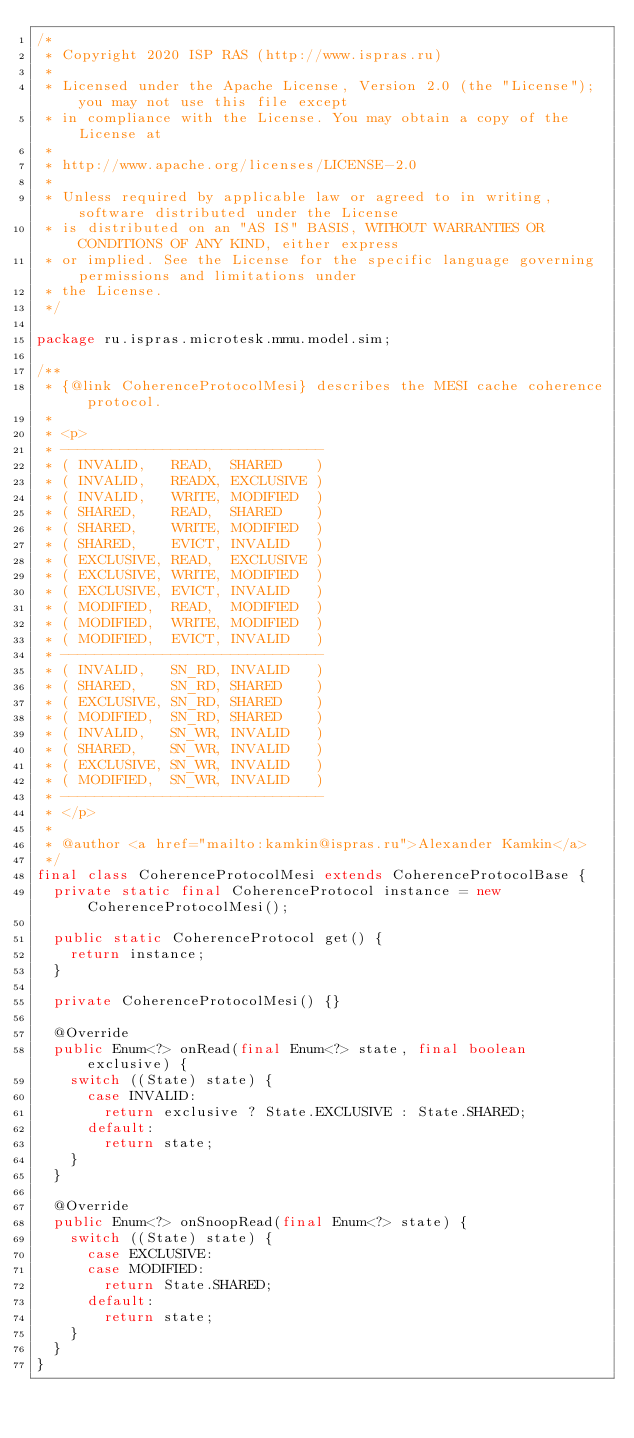Convert code to text. <code><loc_0><loc_0><loc_500><loc_500><_Java_>/*
 * Copyright 2020 ISP RAS (http://www.ispras.ru)
 *
 * Licensed under the Apache License, Version 2.0 (the "License"); you may not use this file except
 * in compliance with the License. You may obtain a copy of the License at
 *
 * http://www.apache.org/licenses/LICENSE-2.0
 *
 * Unless required by applicable law or agreed to in writing, software distributed under the License
 * is distributed on an "AS IS" BASIS, WITHOUT WARRANTIES OR CONDITIONS OF ANY KIND, either express
 * or implied. See the License for the specific language governing permissions and limitations under
 * the License.
 */

package ru.ispras.microtesk.mmu.model.sim;

/**
 * {@link CoherenceProtocolMesi} describes the MESI cache coherence protocol.
 *
 * <p>
 * -------------------------------
 * ( INVALID,   READ,  SHARED    )
 * ( INVALID,   READX, EXCLUSIVE )
 * ( INVALID,   WRITE, MODIFIED  )
 * ( SHARED,    READ,  SHARED    )
 * ( SHARED,    WRITE, MODIFIED  )
 * ( SHARED,    EVICT, INVALID   )
 * ( EXCLUSIVE, READ,  EXCLUSIVE )
 * ( EXCLUSIVE, WRITE, MODIFIED  )
 * ( EXCLUSIVE, EVICT, INVALID   )
 * ( MODIFIED,  READ,  MODIFIED  )
 * ( MODIFIED,  WRITE, MODIFIED  )
 * ( MODIFIED,  EVICT, INVALID   )
 * -------------------------------
 * ( INVALID,   SN_RD, INVALID   )
 * ( SHARED,    SN_RD, SHARED    )
 * ( EXCLUSIVE, SN_RD, SHARED    )
 * ( MODIFIED,  SN_RD, SHARED    )
 * ( INVALID,   SN_WR, INVALID   )
 * ( SHARED,    SN_WR, INVALID   )
 * ( EXCLUSIVE, SN_WR, INVALID   )
 * ( MODIFIED,  SN_WR, INVALID   )
 * -------------------------------
 * </p>
 *
 * @author <a href="mailto:kamkin@ispras.ru">Alexander Kamkin</a>
 */
final class CoherenceProtocolMesi extends CoherenceProtocolBase {
  private static final CoherenceProtocol instance = new CoherenceProtocolMesi();

  public static CoherenceProtocol get() {
    return instance;
  }

  private CoherenceProtocolMesi() {}

  @Override
  public Enum<?> onRead(final Enum<?> state, final boolean exclusive) {
    switch ((State) state) {
      case INVALID:
        return exclusive ? State.EXCLUSIVE : State.SHARED;
      default:
        return state;
    }
  }

  @Override
  public Enum<?> onSnoopRead(final Enum<?> state) {
    switch ((State) state) {
      case EXCLUSIVE:
      case MODIFIED:
        return State.SHARED;
      default:
        return state;
    }
  }
}
</code> 